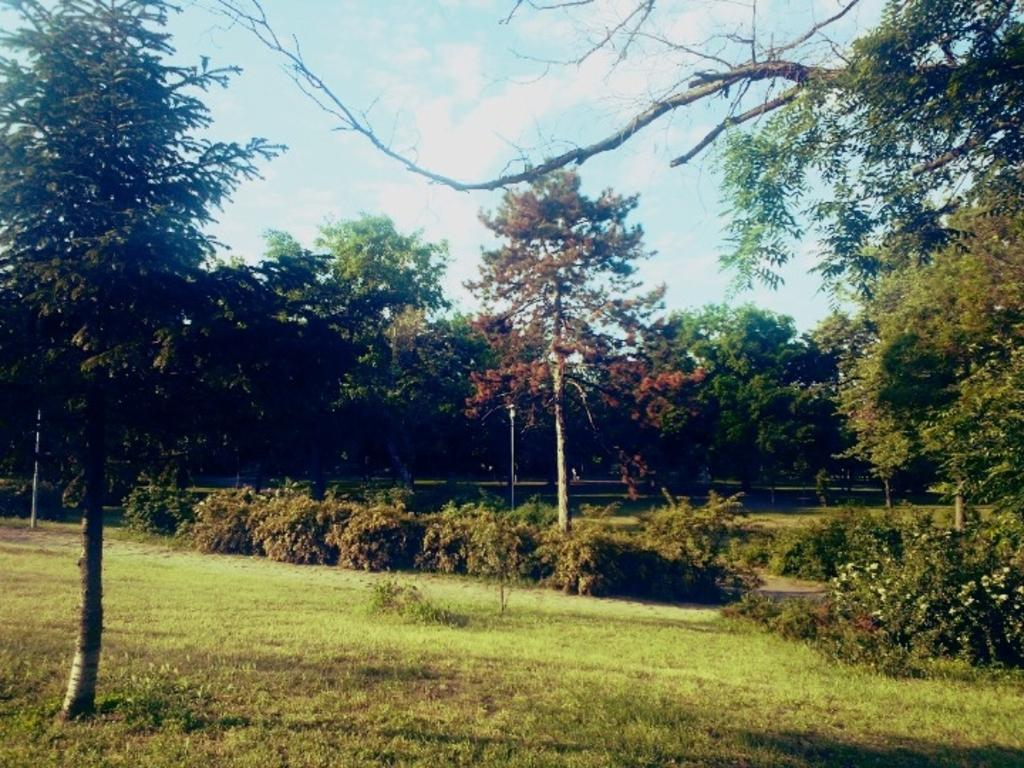What type of vegetation can be seen in the image? There is grass, plants, flowers, and trees in the image. What are the poles used for in the image? The purpose of the poles is not specified in the image. What is visible in the background of the image? The sky is visible in the background of the image, with clouds present. What type of decision is being made by the toad in the image? There is no toad present in the image, so no decision can be made by a toad. Is the gun being used by anyone in the image? There is no gun present in the image. 